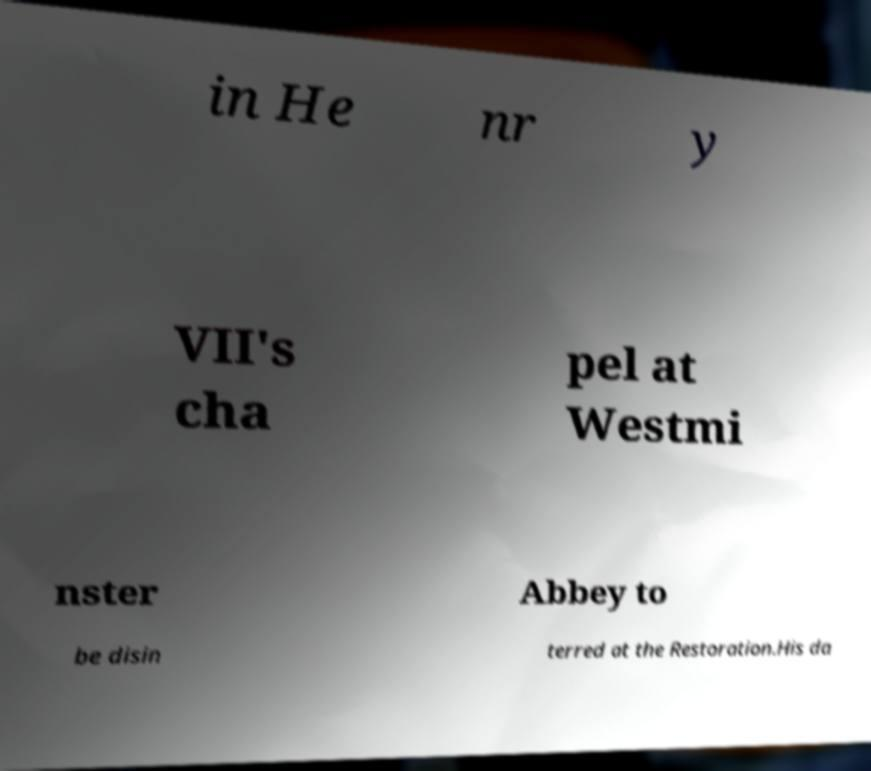Could you extract and type out the text from this image? in He nr y VII's cha pel at Westmi nster Abbey to be disin terred at the Restoration.His da 